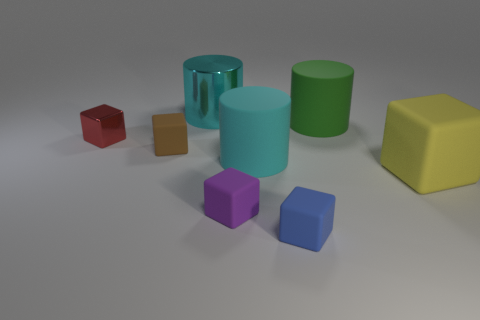There is a thing that is the same color as the metallic cylinder; what is its material?
Provide a succinct answer. Rubber. What number of big matte cylinders are the same color as the big metal thing?
Make the answer very short. 1. What number of things are either tiny purple rubber things or large things in front of the large cyan metallic object?
Provide a short and direct response. 4. What is the material of the tiny object behind the rubber cube that is behind the matte cube right of the blue rubber thing?
Offer a very short reply. Metal. There is a large rubber cylinder in front of the green matte object; is it the same color as the large metallic object?
Offer a very short reply. Yes. What number of cyan things are large objects or large rubber spheres?
Your answer should be very brief. 2. How many other things are there of the same shape as the brown matte thing?
Keep it short and to the point. 4. Are the purple thing and the red thing made of the same material?
Offer a very short reply. No. There is a large object that is on the left side of the green object and behind the tiny red cube; what is it made of?
Ensure brevity in your answer.  Metal. There is a metal thing behind the tiny metallic object; what color is it?
Make the answer very short. Cyan. 